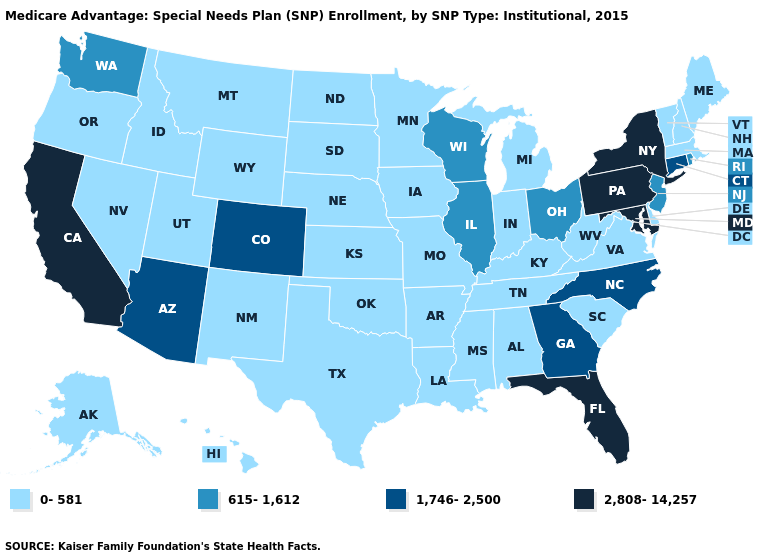Name the states that have a value in the range 615-1,612?
Write a very short answer. Illinois, New Jersey, Ohio, Rhode Island, Washington, Wisconsin. What is the value of Ohio?
Concise answer only. 615-1,612. Among the states that border Texas , which have the lowest value?
Write a very short answer. Arkansas, Louisiana, New Mexico, Oklahoma. Does Hawaii have the highest value in the USA?
Quick response, please. No. Among the states that border Wyoming , does Nebraska have the lowest value?
Be succinct. Yes. What is the value of Vermont?
Keep it brief. 0-581. Does Illinois have a lower value than New York?
Concise answer only. Yes. Is the legend a continuous bar?
Give a very brief answer. No. What is the lowest value in the Northeast?
Write a very short answer. 0-581. Does North Dakota have the lowest value in the USA?
Concise answer only. Yes. Does New Jersey have a lower value than Colorado?
Be succinct. Yes. What is the lowest value in the USA?
Short answer required. 0-581. Which states have the lowest value in the West?
Be succinct. Alaska, Hawaii, Idaho, Montana, New Mexico, Nevada, Oregon, Utah, Wyoming. Name the states that have a value in the range 1,746-2,500?
Concise answer only. Arizona, Colorado, Connecticut, Georgia, North Carolina. Which states have the lowest value in the Northeast?
Short answer required. Massachusetts, Maine, New Hampshire, Vermont. 